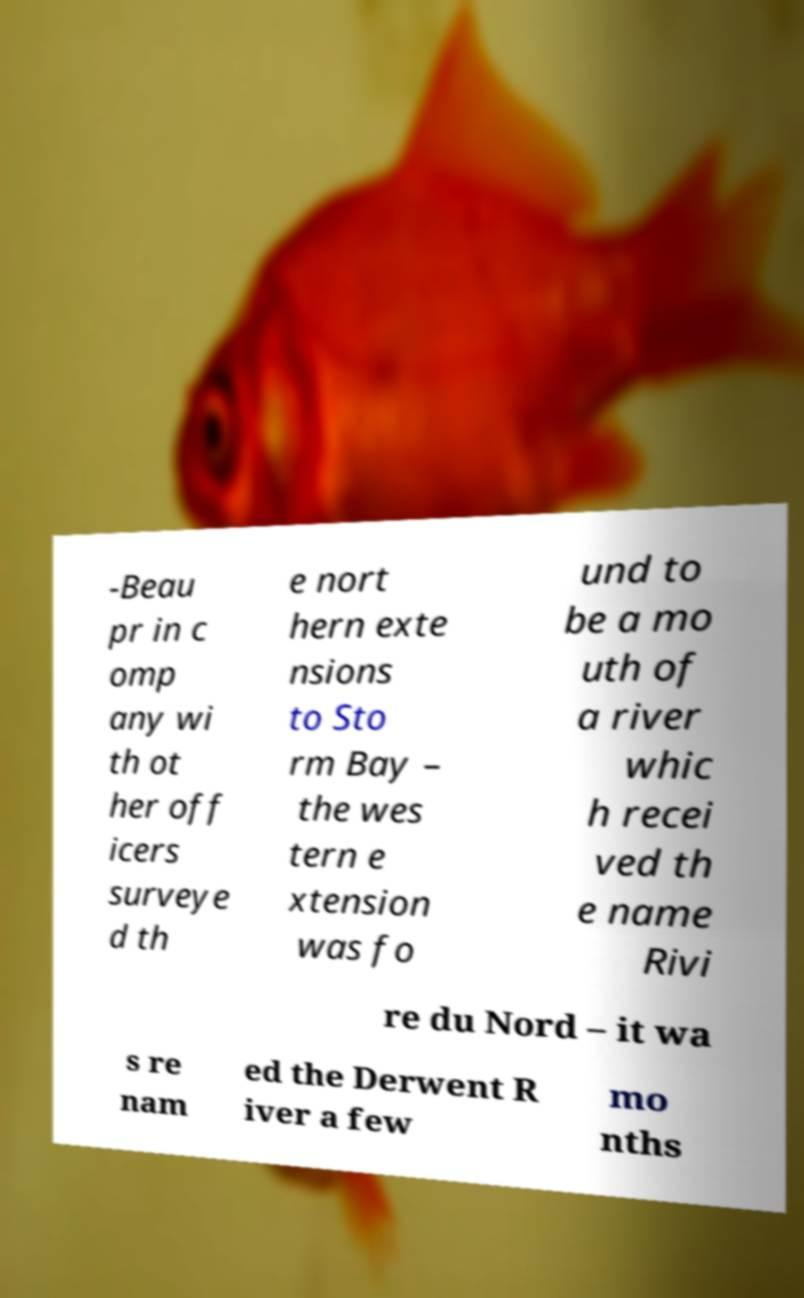I need the written content from this picture converted into text. Can you do that? -Beau pr in c omp any wi th ot her off icers surveye d th e nort hern exte nsions to Sto rm Bay – the wes tern e xtension was fo und to be a mo uth of a river whic h recei ved th e name Rivi re du Nord – it wa s re nam ed the Derwent R iver a few mo nths 